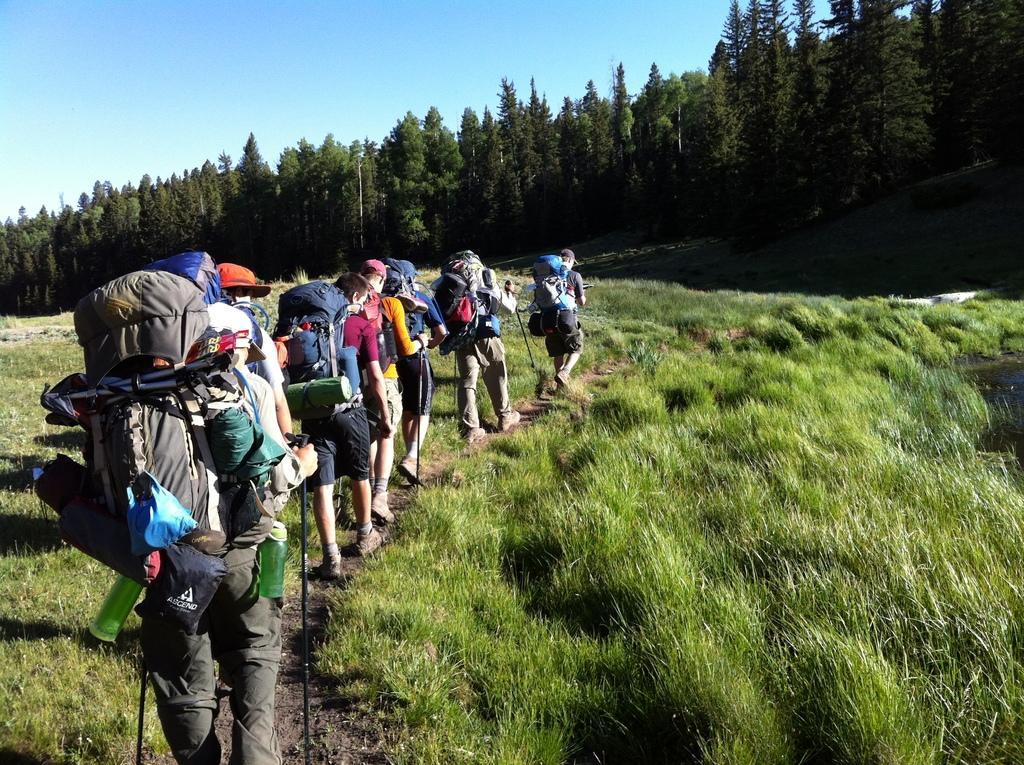How would you summarize this image in a sentence or two? This picture is clicked outside. In the foreground we can see the green grass and the group of people wearing backpacks, holding the metal sticks and walking on the ground. In the background we can see the sky, trees and some other items. 